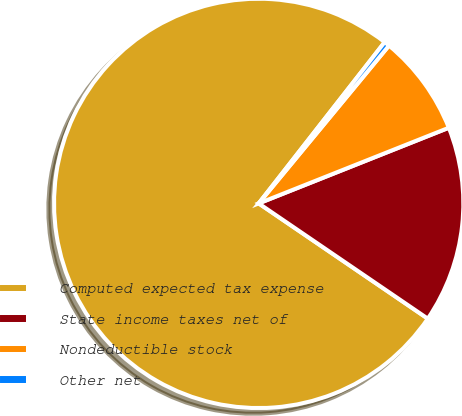Convert chart to OTSL. <chart><loc_0><loc_0><loc_500><loc_500><pie_chart><fcel>Computed expected tax expense<fcel>State income taxes net of<fcel>Nondeductible stock<fcel>Other net<nl><fcel>76.04%<fcel>15.55%<fcel>7.99%<fcel>0.43%<nl></chart> 